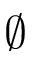<formula> <loc_0><loc_0><loc_500><loc_500>\emptyset</formula> 